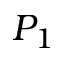Convert formula to latex. <formula><loc_0><loc_0><loc_500><loc_500>P _ { 1 }</formula> 